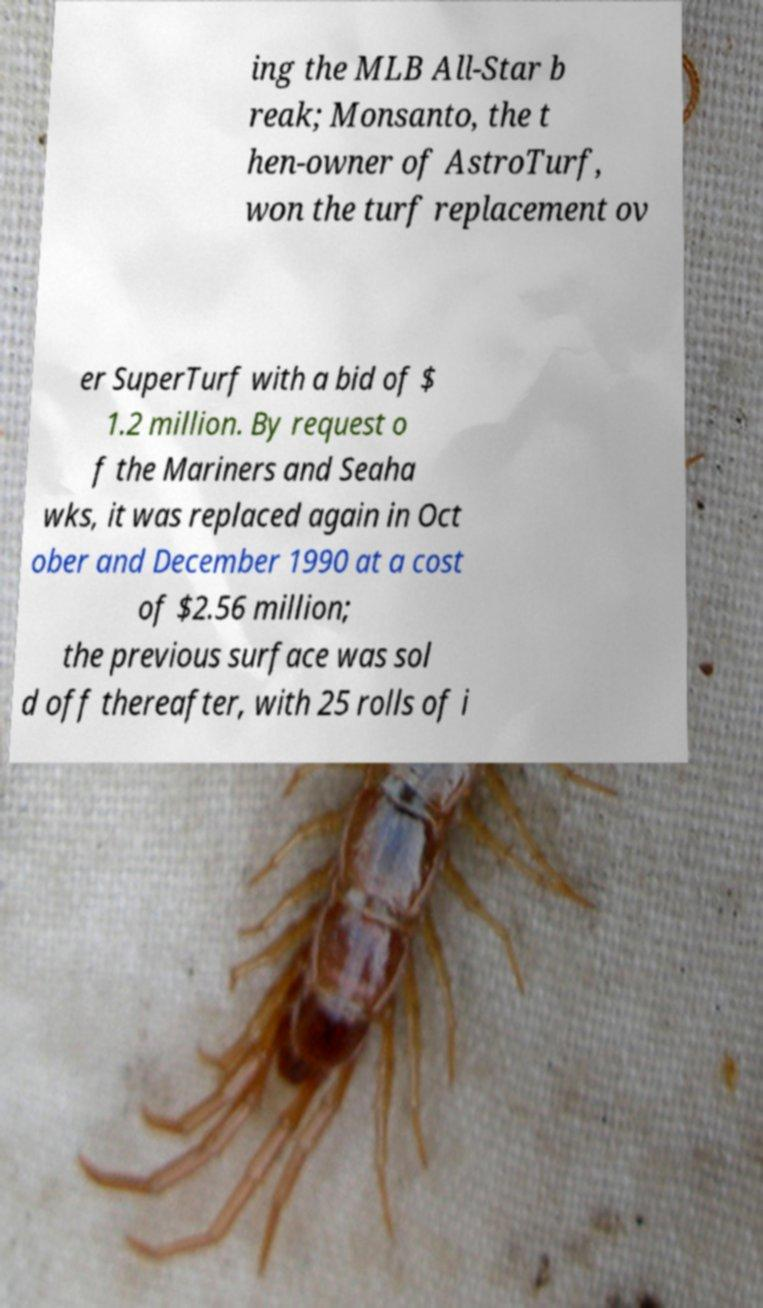There's text embedded in this image that I need extracted. Can you transcribe it verbatim? ing the MLB All-Star b reak; Monsanto, the t hen-owner of AstroTurf, won the turf replacement ov er SuperTurf with a bid of $ 1.2 million. By request o f the Mariners and Seaha wks, it was replaced again in Oct ober and December 1990 at a cost of $2.56 million; the previous surface was sol d off thereafter, with 25 rolls of i 